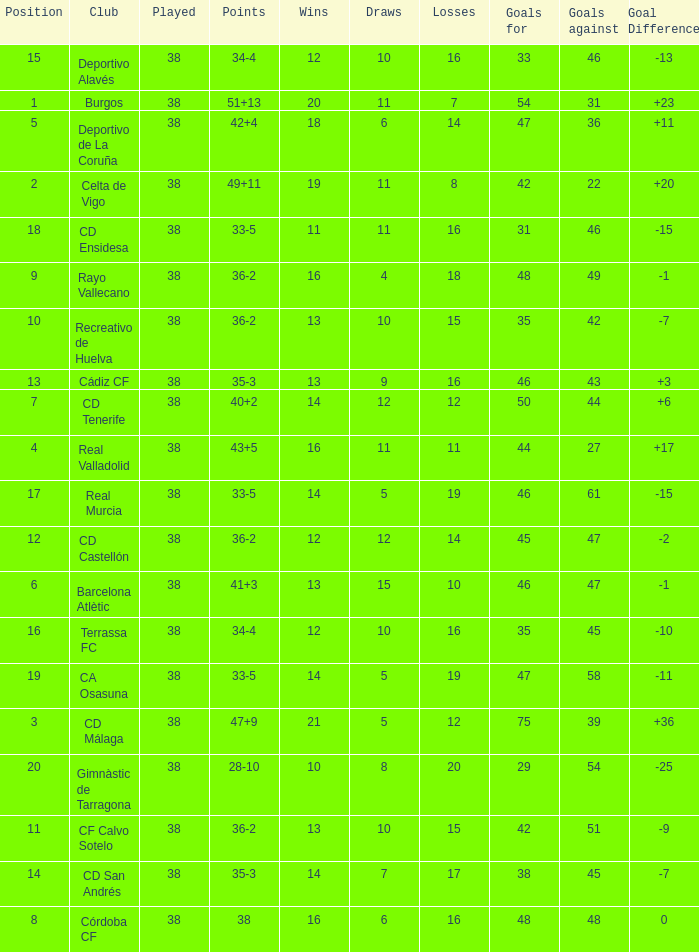How many positions have 14 wins, goals against of 61 and fewer than 19 losses? 0.0. 